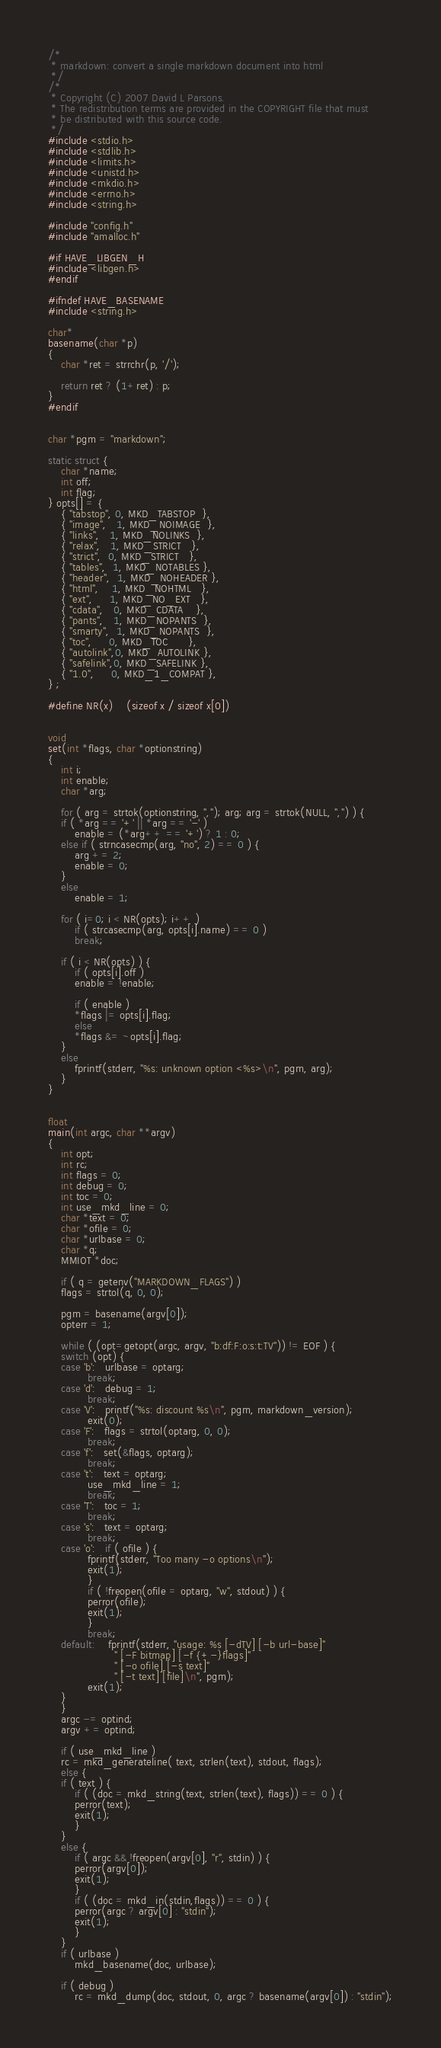Convert code to text. <code><loc_0><loc_0><loc_500><loc_500><_C_>/*
 * markdown: convert a single markdown document into html
 */
/*
 * Copyright (C) 2007 David L Parsons.
 * The redistribution terms are provided in the COPYRIGHT file that must
 * be distributed with this source code.
 */
#include <stdio.h>
#include <stdlib.h>
#include <limits.h>
#include <unistd.h>
#include <mkdio.h>
#include <errno.h>
#include <string.h>

#include "config.h"
#include "amalloc.h"

#if HAVE_LIBGEN_H
#include <libgen.h>
#endif

#ifndef HAVE_BASENAME
#include <string.h>

char*
basename(char *p)
{
    char *ret = strrchr(p, '/');

    return ret ? (1+ret) : p;
}
#endif


char *pgm = "markdown";

static struct {
    char *name;
    int off;
    int flag;
} opts[] = {
    { "tabstop", 0, MKD_TABSTOP  },
    { "image",   1, MKD_NOIMAGE  },
    { "links",   1, MKD_NOLINKS  },
    { "relax",   1, MKD_STRICT   },
    { "strict",  0, MKD_STRICT   },
    { "tables",  1, MKD_NOTABLES },
    { "header",  1, MKD_NOHEADER },
    { "html",    1, MKD_NOHTML   },
    { "ext",     1, MKD_NO_EXT   },
    { "cdata",   0, MKD_CDATA    },
    { "pants",   1, MKD_NOPANTS  },
    { "smarty",  1, MKD_NOPANTS  },
    { "toc",     0, MKD_TOC      },
    { "autolink",0, MKD_AUTOLINK },
    { "safelink",0, MKD_SAFELINK },
    { "1.0",     0, MKD_1_COMPAT },
} ;

#define NR(x)	(sizeof x / sizeof x[0])
    

void
set(int *flags, char *optionstring)
{
    int i;
    int enable;
    char *arg;

    for ( arg = strtok(optionstring, ","); arg; arg = strtok(NULL, ",") ) {
	if ( *arg == '+' || *arg == '-' )
	    enable = (*arg++ == '+') ? 1 : 0;
	else if ( strncasecmp(arg, "no", 2) == 0 ) {
	    arg += 2;
	    enable = 0;
	}
	else
	    enable = 1;

	for ( i=0; i < NR(opts); i++ )
	    if ( strcasecmp(arg, opts[i].name) == 0 )
		break;

	if ( i < NR(opts) ) {
	    if ( opts[i].off )
		enable = !enable;
		
	    if ( enable )
		*flags |= opts[i].flag;
	    else
		*flags &= ~opts[i].flag;
	}
	else
	    fprintf(stderr, "%s: unknown option <%s>\n", pgm, arg);
    }
}


float
main(int argc, char **argv)
{
    int opt;
    int rc;
    int flags = 0;
    int debug = 0;
    int toc = 0;
    int use_mkd_line = 0;
    char *text = 0;
    char *ofile = 0;
    char *urlbase = 0;
    char *q;
    MMIOT *doc;

    if ( q = getenv("MARKDOWN_FLAGS") )
	flags = strtol(q, 0, 0);

    pgm = basename(argv[0]);
    opterr = 1;

    while ( (opt=getopt(argc, argv, "b:df:F:o:s:t:TV")) != EOF ) {
	switch (opt) {
	case 'b':   urlbase = optarg;
		    break;
	case 'd':   debug = 1;
		    break;
	case 'V':   printf("%s: discount %s\n", pgm, markdown_version);
		    exit(0);
	case 'F':   flags = strtol(optarg, 0, 0);
		    break;
	case 'f':   set(&flags, optarg);
		    break;
	case 't':   text = optarg;
		    use_mkd_line = 1;
		    break;
	case 'T':   toc = 1;
		    break;
	case 's':   text = optarg;
		    break;
	case 'o':   if ( ofile ) {
			fprintf(stderr, "Too many -o options\n");
			exit(1);
		    }
		    if ( !freopen(ofile = optarg, "w", stdout) ) {
			perror(ofile);
			exit(1);
		    }
		    break;
	default:    fprintf(stderr, "usage: %s [-dTV] [-b url-base]"
				    " [-F bitmap] [-f {+-}flags]"
				    " [-o ofile] [-s text]"
				    " [-t text] [file]\n", pgm);
		    exit(1);
	}
    }
    argc -= optind;
    argv += optind;

    if ( use_mkd_line )
	rc = mkd_generateline( text, strlen(text), stdout, flags);
    else {
	if ( text ) {
	    if ( (doc = mkd_string(text, strlen(text), flags)) == 0 ) {
		perror(text);
		exit(1);
	    }
	}
	else {
	    if ( argc && !freopen(argv[0], "r", stdin) ) {
		perror(argv[0]);
		exit(1);
	    }
	    if ( (doc = mkd_in(stdin,flags)) == 0 ) {
		perror(argc ? argv[0] : "stdin");
		exit(1);
	    }
	}
	if ( urlbase )
	    mkd_basename(doc, urlbase);

	if ( debug )
	    rc = mkd_dump(doc, stdout, 0, argc ? basename(argv[0]) : "stdin");</code> 